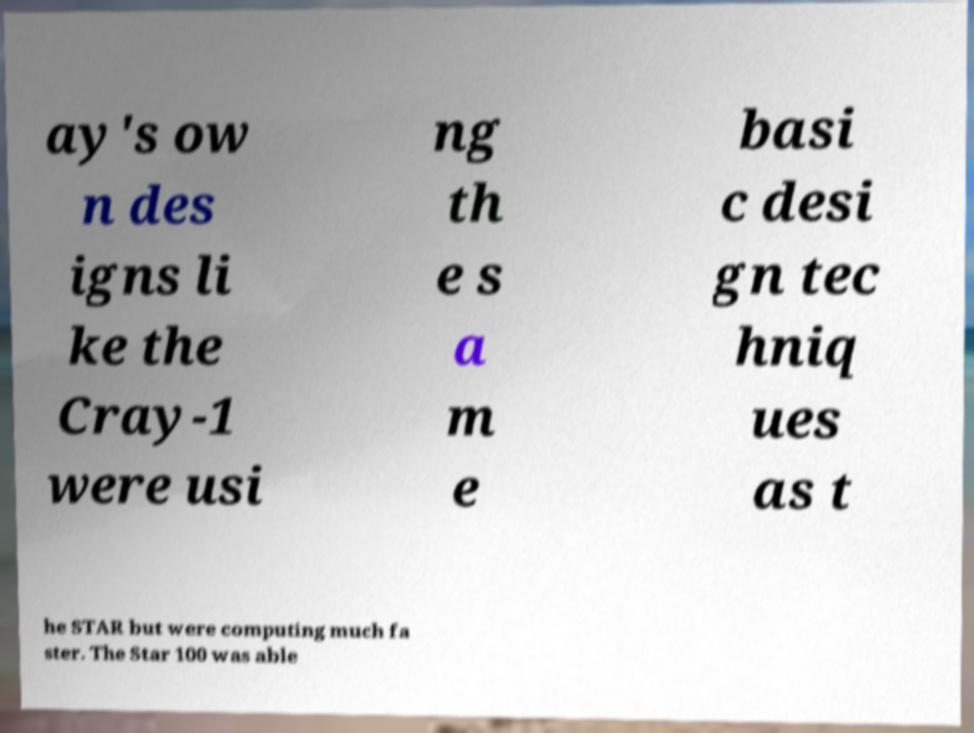Could you assist in decoding the text presented in this image and type it out clearly? ay's ow n des igns li ke the Cray-1 were usi ng th e s a m e basi c desi gn tec hniq ues as t he STAR but were computing much fa ster. The Star 100 was able 